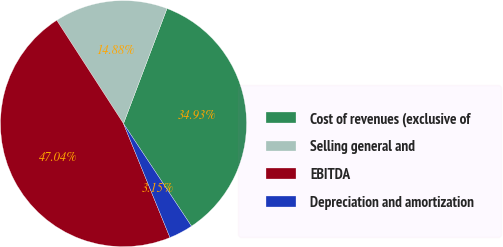Convert chart. <chart><loc_0><loc_0><loc_500><loc_500><pie_chart><fcel>Cost of revenues (exclusive of<fcel>Selling general and<fcel>EBITDA<fcel>Depreciation and amortization<nl><fcel>34.93%<fcel>14.88%<fcel>47.04%<fcel>3.15%<nl></chart> 